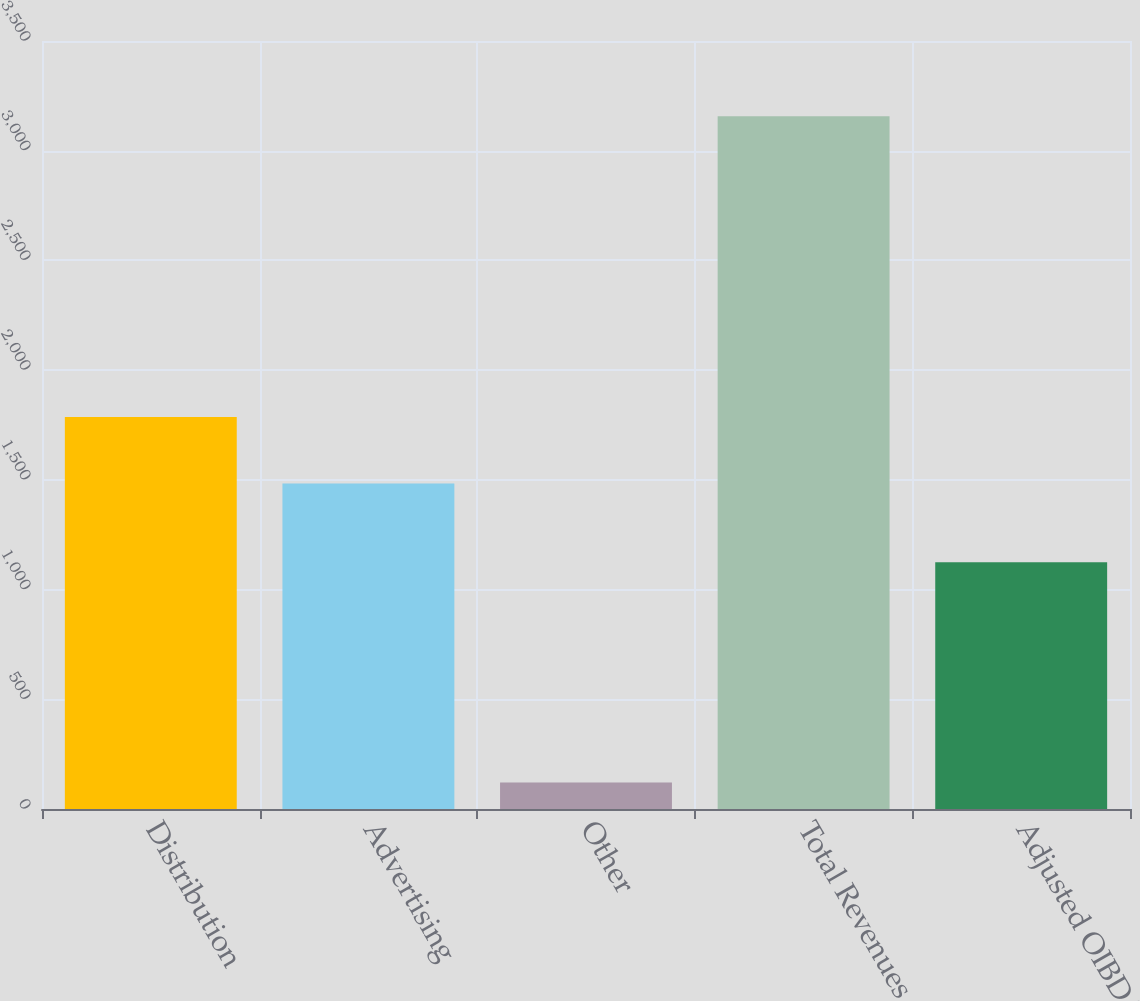Convert chart. <chart><loc_0><loc_0><loc_500><loc_500><bar_chart><fcel>Distribution<fcel>Advertising<fcel>Other<fcel>Total Revenues<fcel>Adjusted OIBDA<nl><fcel>1786.6<fcel>1483<fcel>121<fcel>3157<fcel>1124<nl></chart> 